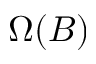Convert formula to latex. <formula><loc_0><loc_0><loc_500><loc_500>\Omega ( B )</formula> 